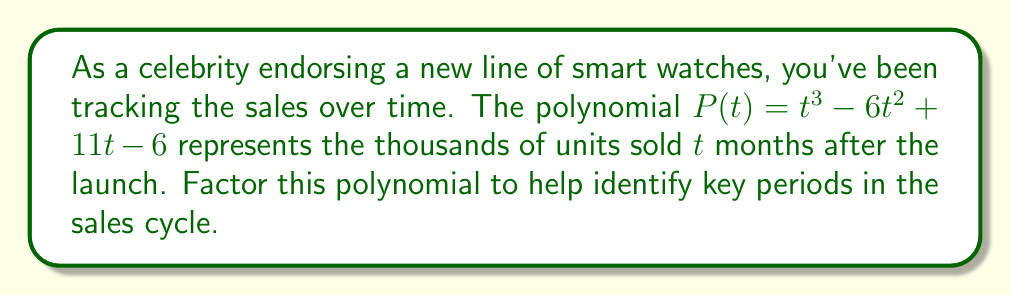What is the answer to this math problem? To factor this cubic polynomial, we'll follow these steps:

1) First, let's check if there's a rational root. We can use the rational root theorem to list possible roots: $\pm 1, \pm 2, \pm 3, \pm 6$.

2) By testing these values, we find that $P(1) = 0$. So $(t-1)$ is a factor.

3) We can use polynomial long division to divide $P(t)$ by $(t-1)$:

   $$\frac{t^3 - 6t^2 + 11t - 6}{t-1} = t^2 - 5t + 6$$

4) Now we have: $P(t) = (t-1)(t^2 - 5t + 6)$

5) The quadratic factor $t^2 - 5t + 6$ can be factored further:
   
   $$t^2 - 5t + 6 = (t-2)(t-3)$$

6) Combining all factors, we get:

   $$P(t) = (t-1)(t-2)(t-3)$$

This factorization shows that sales hit key points at 1, 2, and 3 months after launch.
Answer: $P(t) = (t-1)(t-2)(t-3)$ 